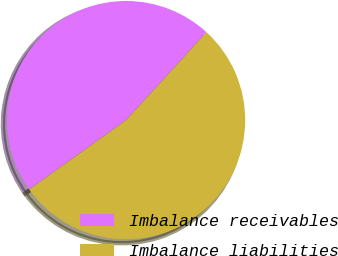<chart> <loc_0><loc_0><loc_500><loc_500><pie_chart><fcel>Imbalance receivables<fcel>Imbalance liabilities<nl><fcel>46.67%<fcel>53.33%<nl></chart> 